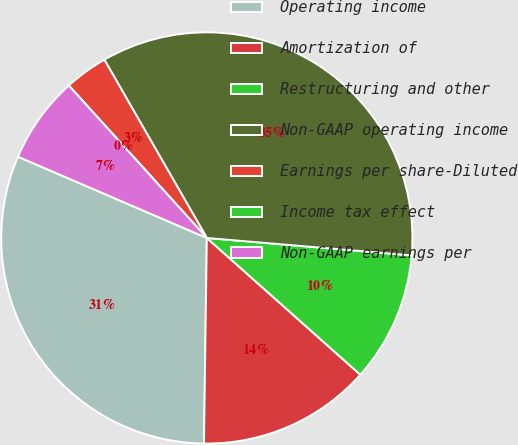<chart> <loc_0><loc_0><loc_500><loc_500><pie_chart><fcel>Operating income<fcel>Amortization of<fcel>Restructuring and other<fcel>Non-GAAP operating income<fcel>Earnings per share-Diluted<fcel>Income tax effect<fcel>Non-GAAP earnings per<nl><fcel>31.25%<fcel>13.64%<fcel>10.23%<fcel>34.66%<fcel>3.41%<fcel>0.0%<fcel>6.82%<nl></chart> 